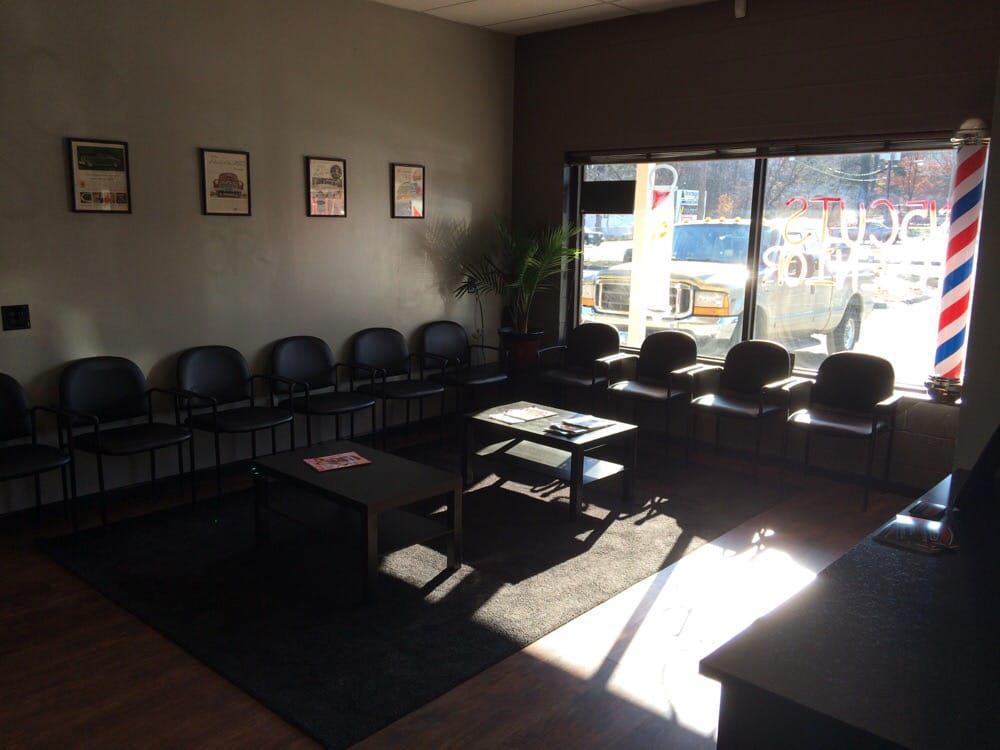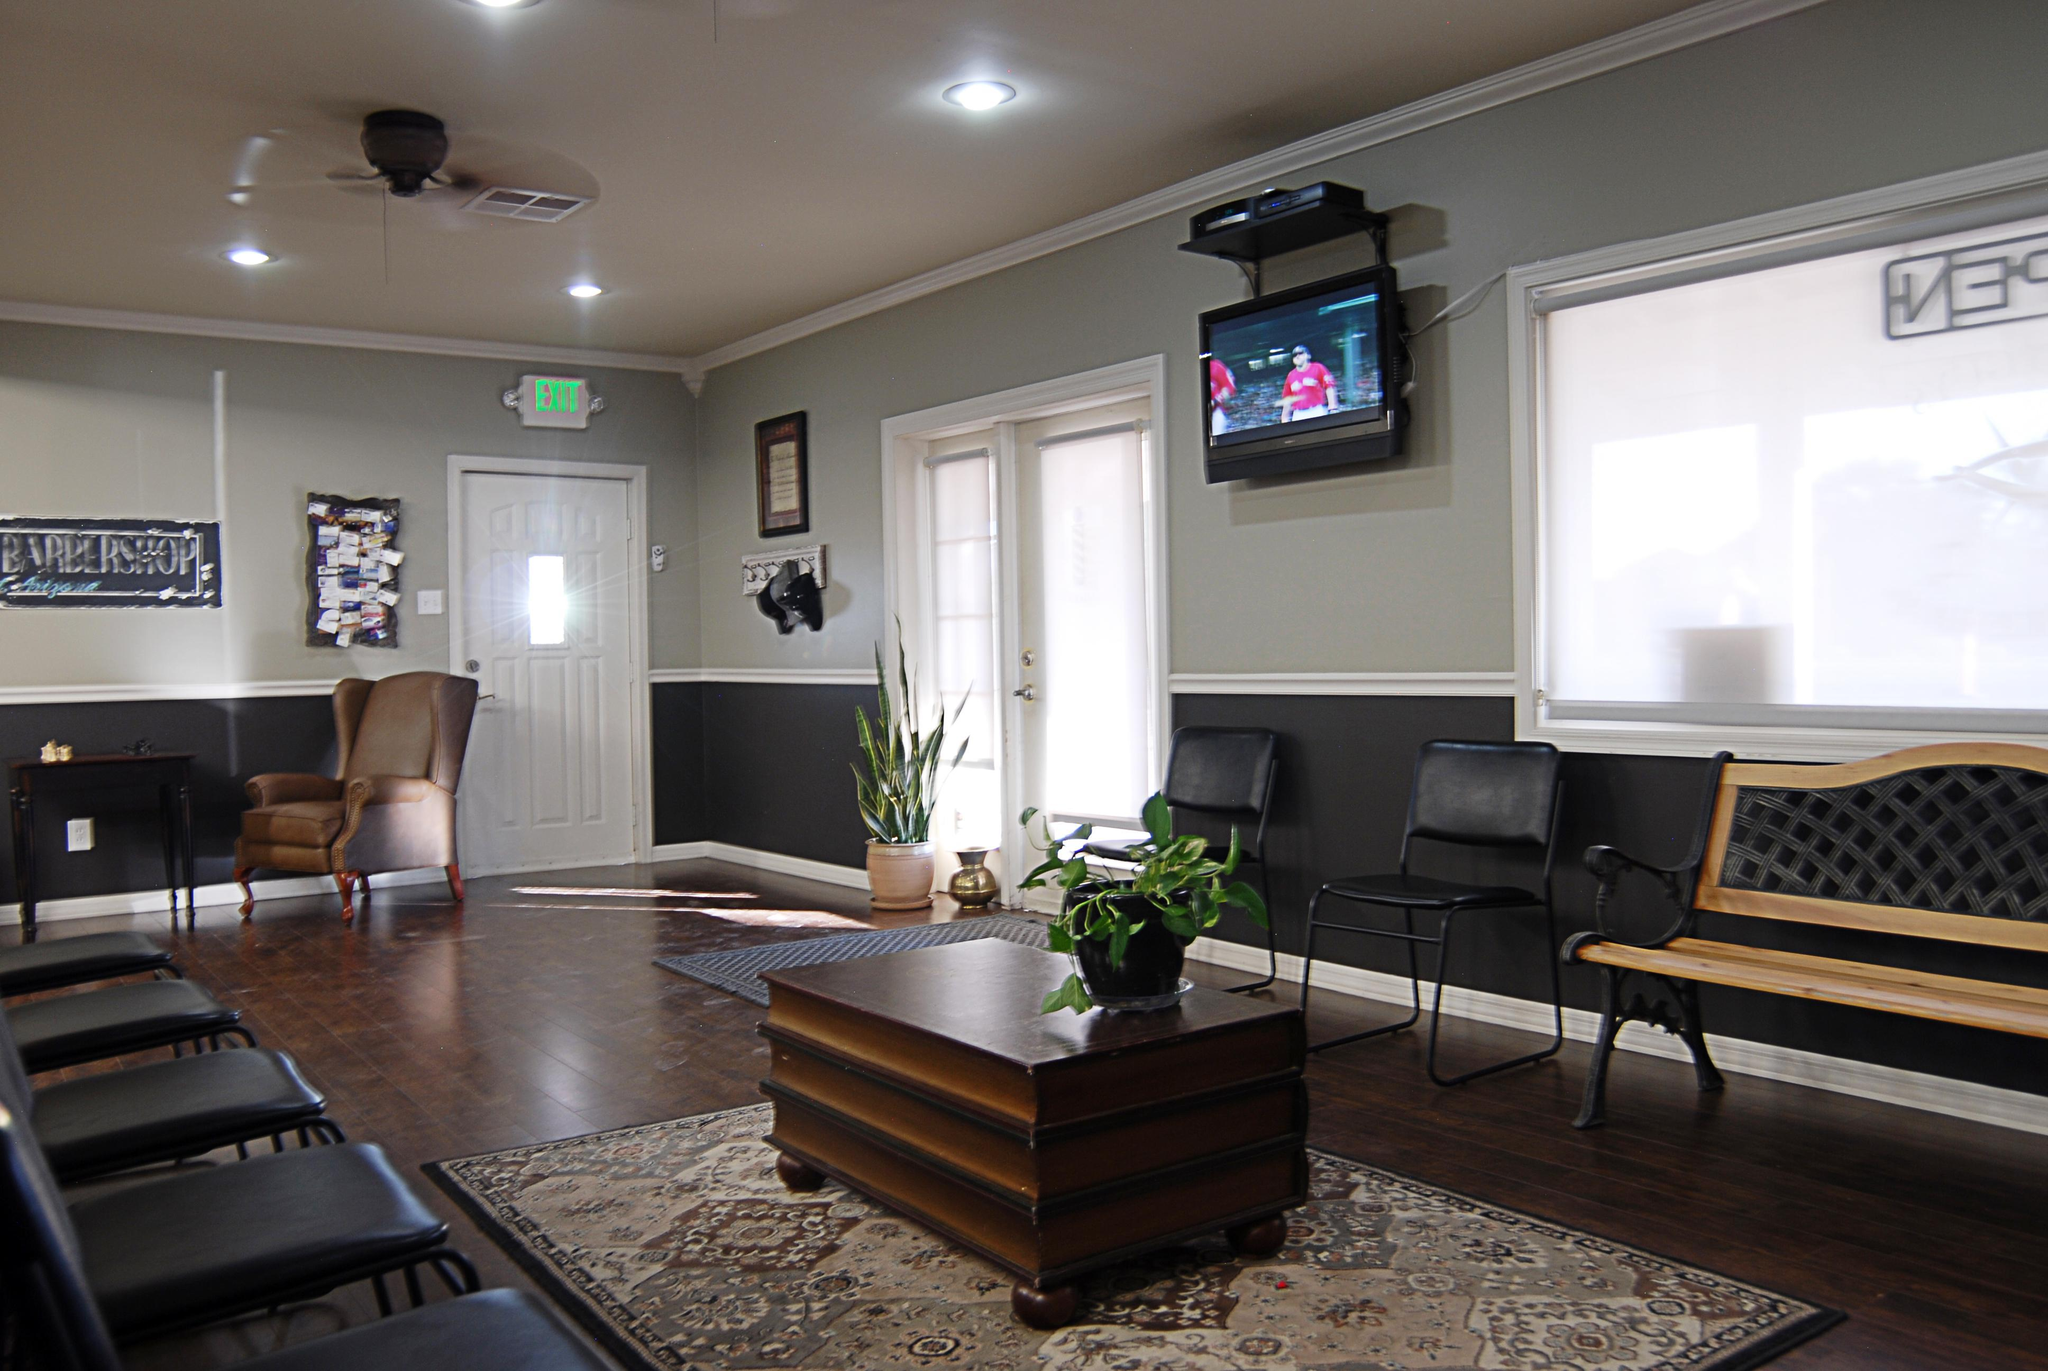The first image is the image on the left, the second image is the image on the right. Evaluate the accuracy of this statement regarding the images: "In one of the image there is at least one man sitting down on a couch.". Is it true? Answer yes or no. No. The first image is the image on the left, the second image is the image on the right. Analyze the images presented: Is the assertion "There is no more than two flat screen televisions in the right image." valid? Answer yes or no. Yes. 